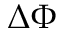<formula> <loc_0><loc_0><loc_500><loc_500>\Delta \Phi</formula> 